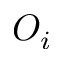<formula> <loc_0><loc_0><loc_500><loc_500>O _ { i }</formula> 